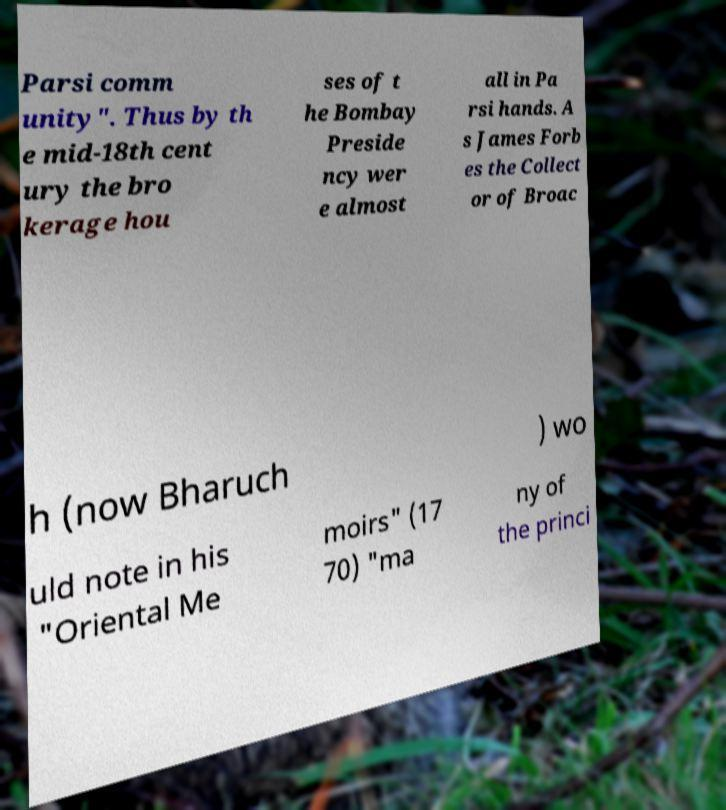Could you assist in decoding the text presented in this image and type it out clearly? Parsi comm unity". Thus by th e mid-18th cent ury the bro kerage hou ses of t he Bombay Preside ncy wer e almost all in Pa rsi hands. A s James Forb es the Collect or of Broac h (now Bharuch ) wo uld note in his "Oriental Me moirs" (17 70) "ma ny of the princi 